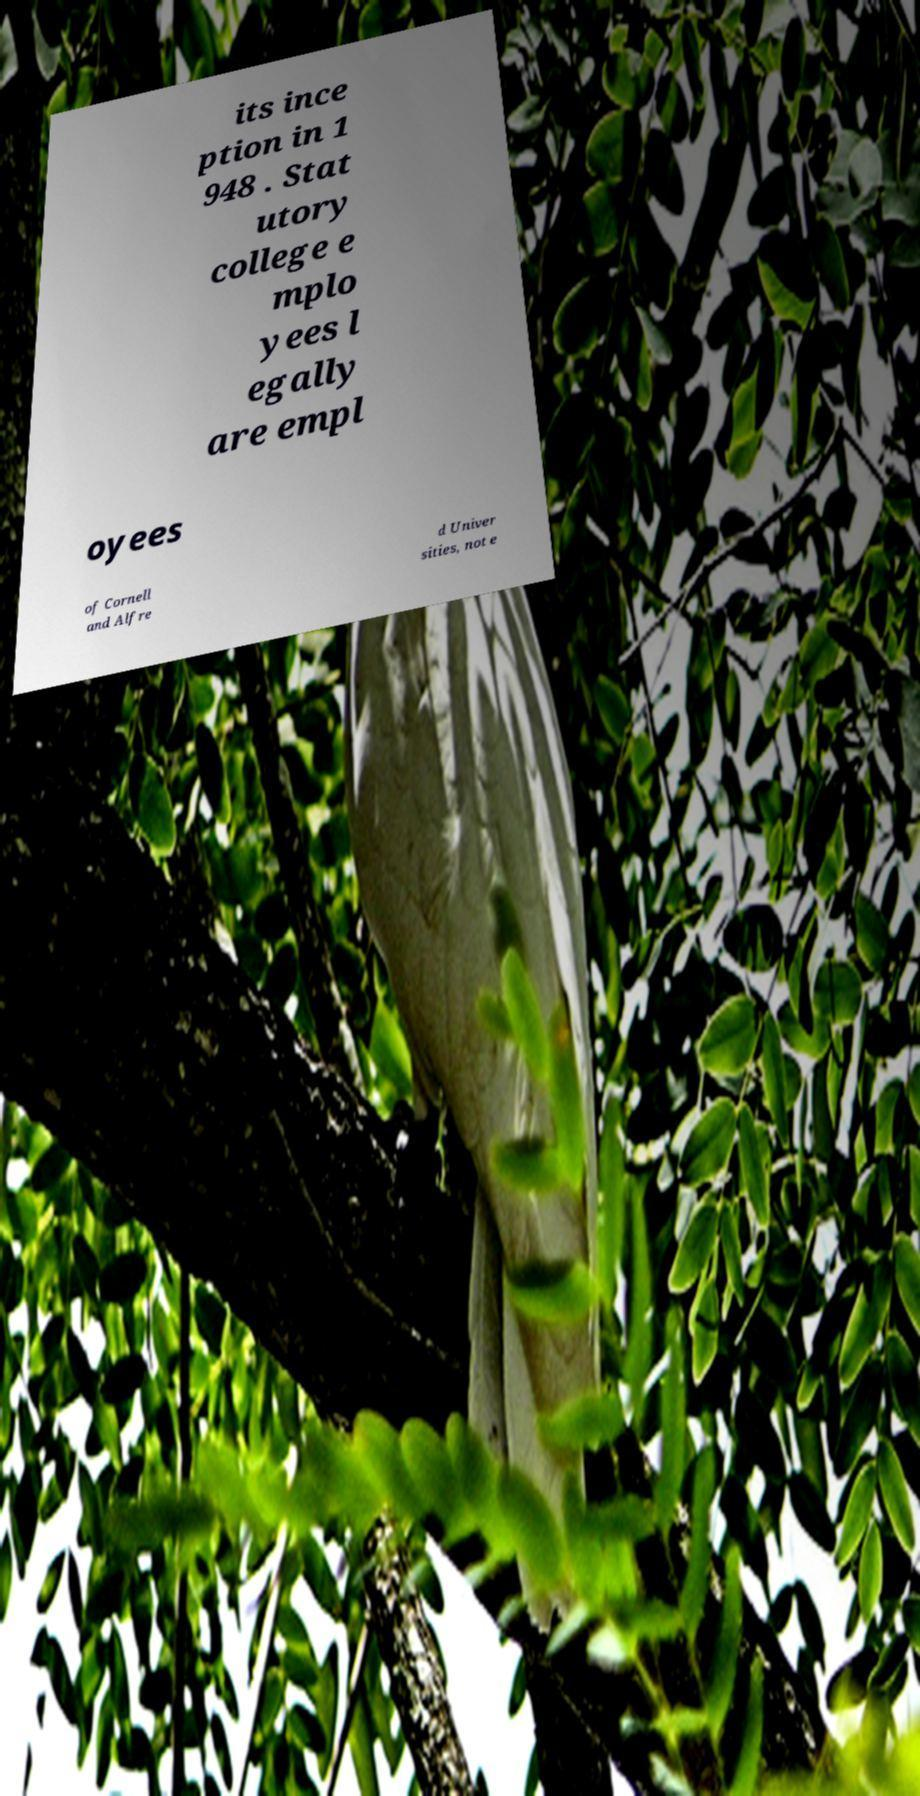Please identify and transcribe the text found in this image. its ince ption in 1 948 . Stat utory college e mplo yees l egally are empl oyees of Cornell and Alfre d Univer sities, not e 